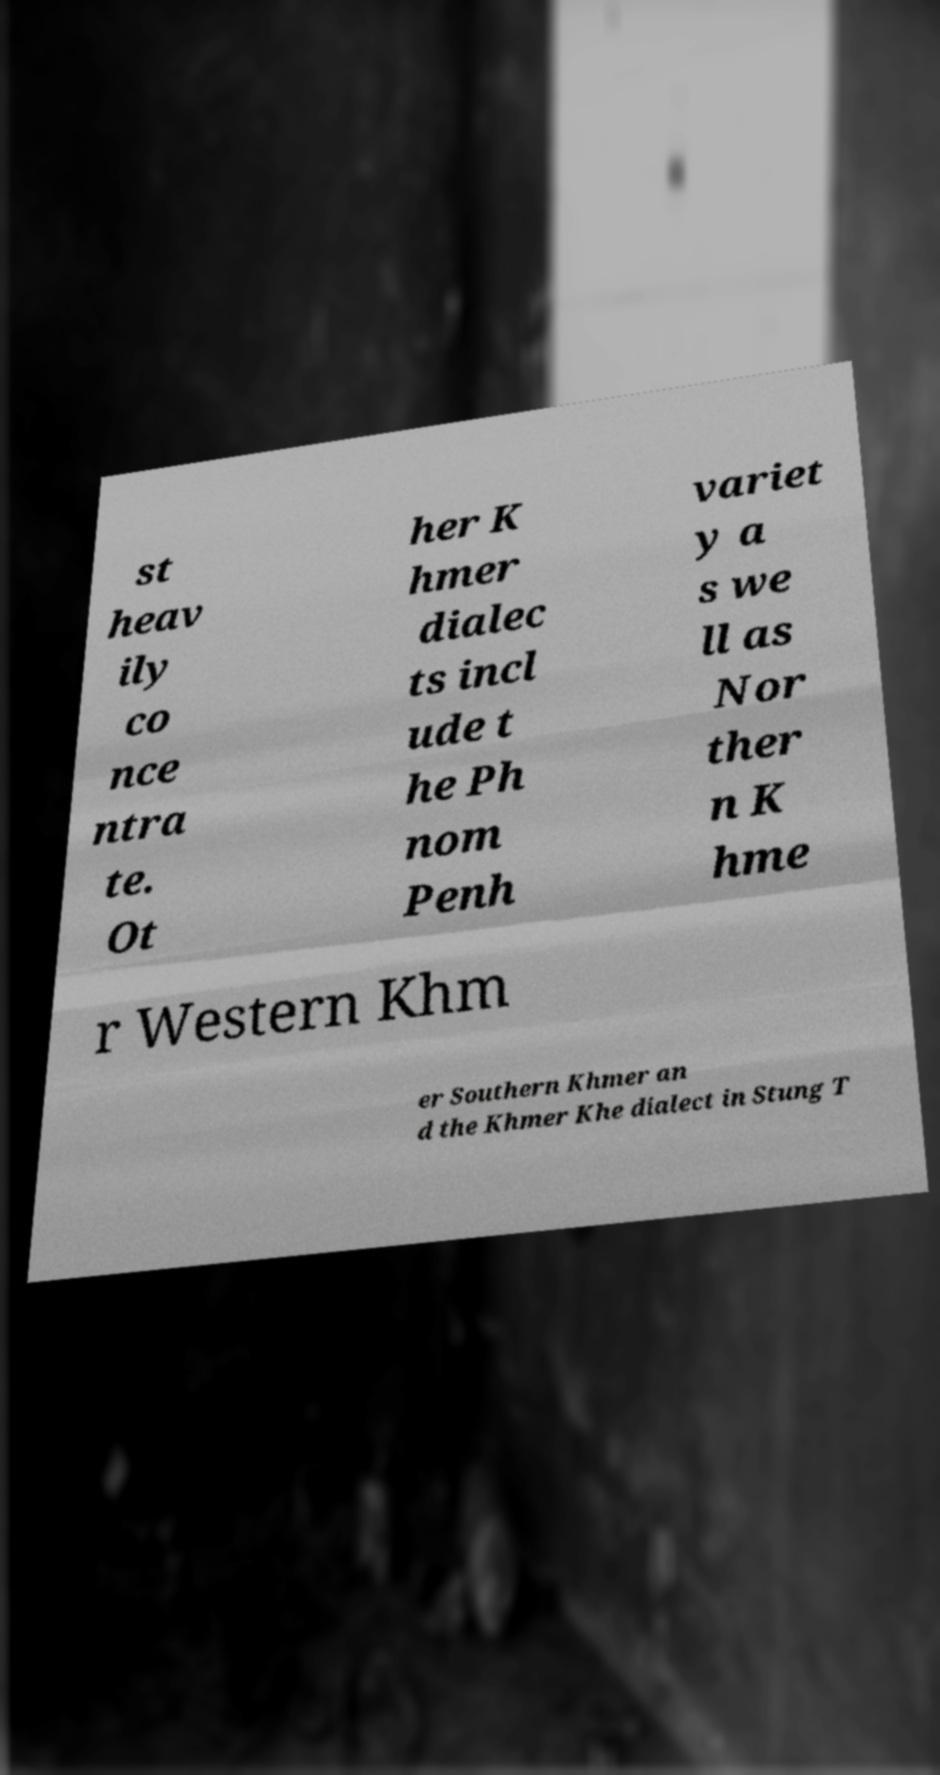Please identify and transcribe the text found in this image. st heav ily co nce ntra te. Ot her K hmer dialec ts incl ude t he Ph nom Penh variet y a s we ll as Nor ther n K hme r Western Khm er Southern Khmer an d the Khmer Khe dialect in Stung T 